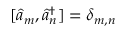<formula> <loc_0><loc_0><loc_500><loc_500>[ \hat { a } _ { m } , \hat { a } _ { n } ^ { \dag } ] = \delta _ { m , n }</formula> 